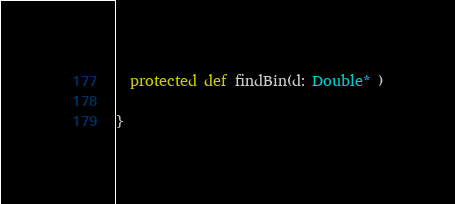Convert code to text. <code><loc_0><loc_0><loc_500><loc_500><_Scala_>  protected def findBin(d: Double* )

}
</code> 